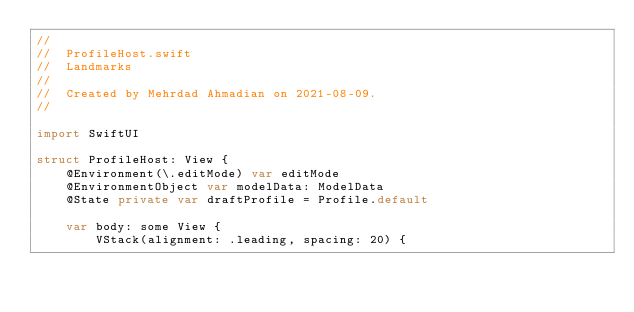Convert code to text. <code><loc_0><loc_0><loc_500><loc_500><_Swift_>//
//  ProfileHost.swift
//  Landmarks
//
//  Created by Mehrdad Ahmadian on 2021-08-09.
//

import SwiftUI

struct ProfileHost: View {
    @Environment(\.editMode) var editMode
    @EnvironmentObject var modelData: ModelData
    @State private var draftProfile = Profile.default

    var body: some View {
        VStack(alignment: .leading, spacing: 20) {</code> 